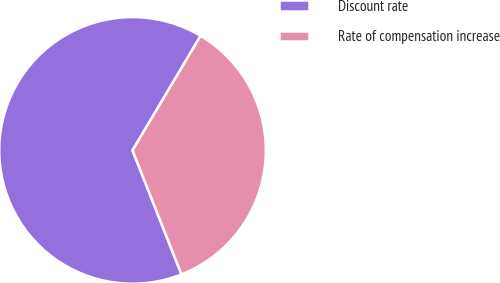Convert chart to OTSL. <chart><loc_0><loc_0><loc_500><loc_500><pie_chart><fcel>Discount rate<fcel>Rate of compensation increase<nl><fcel>64.52%<fcel>35.48%<nl></chart> 